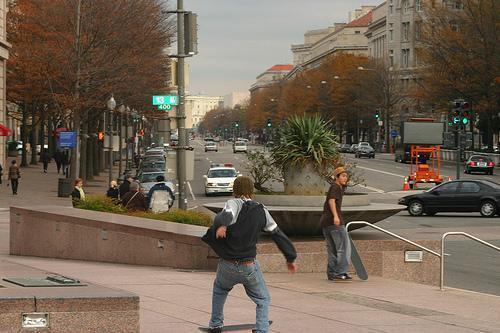How many police cars are in the image?
Give a very brief answer. 1. 